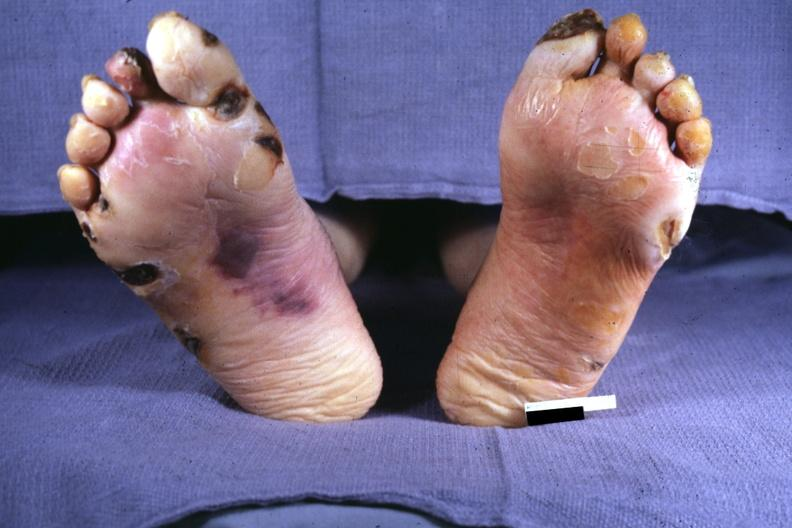does this image show typical gangrene?
Answer the question using a single word or phrase. Yes 